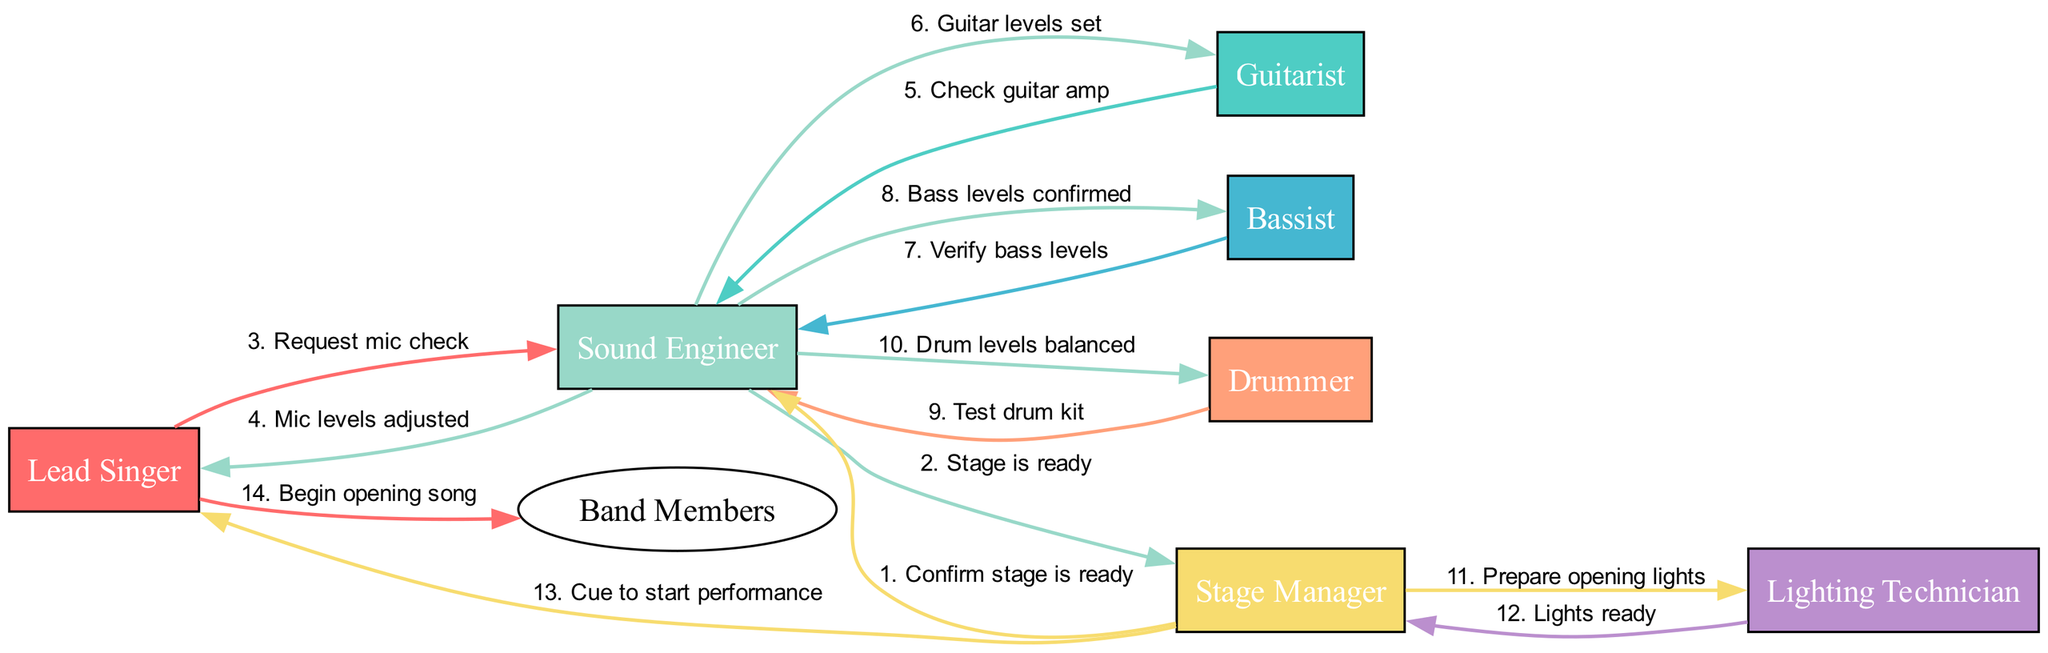What is the first message sent in the sequence? The first message is sent from the Stage Manager to the Sound Engineer, confirming that the stage is ready. This is the first interaction depicted in the sequence.
Answer: Confirm stage is ready How many actors are involved in the diagram? The diagram features six unique actors: Lead Singer, Guitarist, Bassist, Drummer, Sound Engineer, Stage Manager, and Lighting Technician. Counting them gives us the total number of actors.
Answer: 7 Who is responsible for adjusting the mic levels? The Sound Engineer is the one who adjusts the mic levels after the Lead Singer requests a mic check. This role is specifically highlighted in the interaction.
Answer: Sound Engineer What is the last action performed before the performance begins? The last action before the performance begins is the cue to the Lead Singer from the Stage Manager, which indicates it’s time to start the performance. This marks the end of the setup sequence.
Answer: Cue to start performance Which actor checks the drum kit? The Drummer is the one who tests the drum kit, as indicated in the sequence where the Drummer interacts with the Sound Engineer. This is listed among the preparation steps leading to the concert.
Answer: Drummer How many messages are exchanged between the Stage Manager and the Lighting Technician? Only two messages are exchanged between the Stage Manager and the Lighting Technician. The Stage Manager prepares for the opening lights and confirms that the lights are ready, which constitutes the complete exchange.
Answer: 2 What is the relationship between the Lead Singer and the Band Members? The Lead Singer communicates with the Band Members to begin the opening song, establishing a direct connection from the Lead Singer to the group as a whole right before the performance starts.
Answer: Begin opening song What content is involved in the second last interaction? The second last interaction is the message from the Stage Manager to the Lead Singer, which is a cue to start the performance. This indicates preparation just before the performance.
Answer: Cue to start performance Which actor is involved in verifying bass levels? The Bassist is responsible for verifying the bass levels in the sequence of interactions, demonstrating their role in the sound-checking process before the concert.
Answer: Bassist 